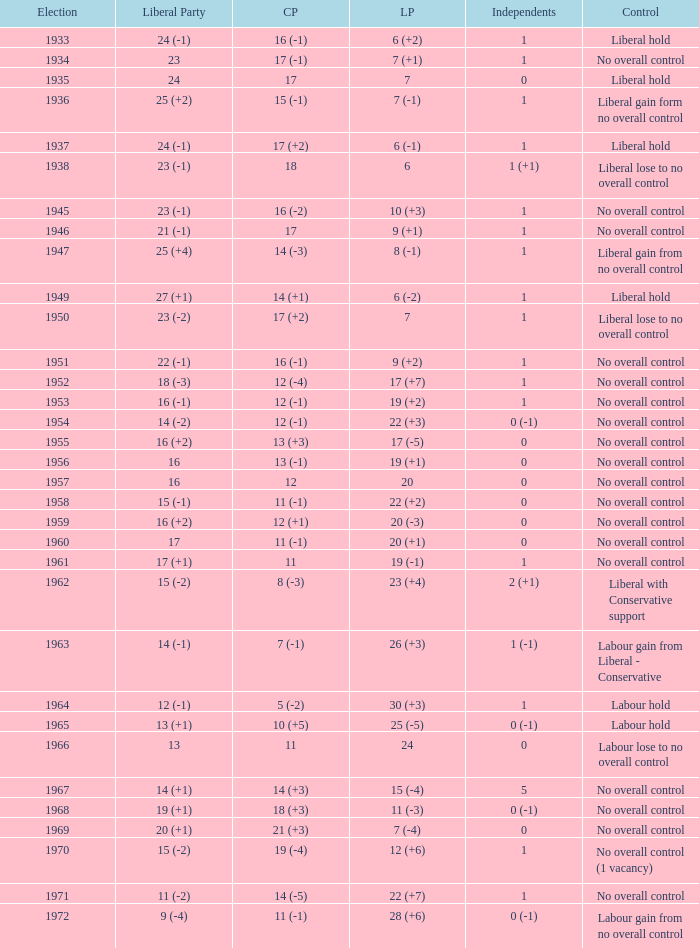Who was in control the year that Labour Party won 12 (+6) seats? No overall control (1 vacancy). 